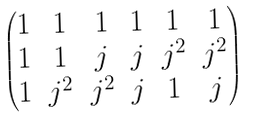Convert formula to latex. <formula><loc_0><loc_0><loc_500><loc_500>\begin{pmatrix} 1 & 1 & 1 & 1 & 1 & 1 \\ 1 & 1 & j & j & j ^ { 2 } & j ^ { 2 } \\ 1 & j ^ { 2 } & j ^ { 2 } & j & 1 & j \end{pmatrix}</formula> 